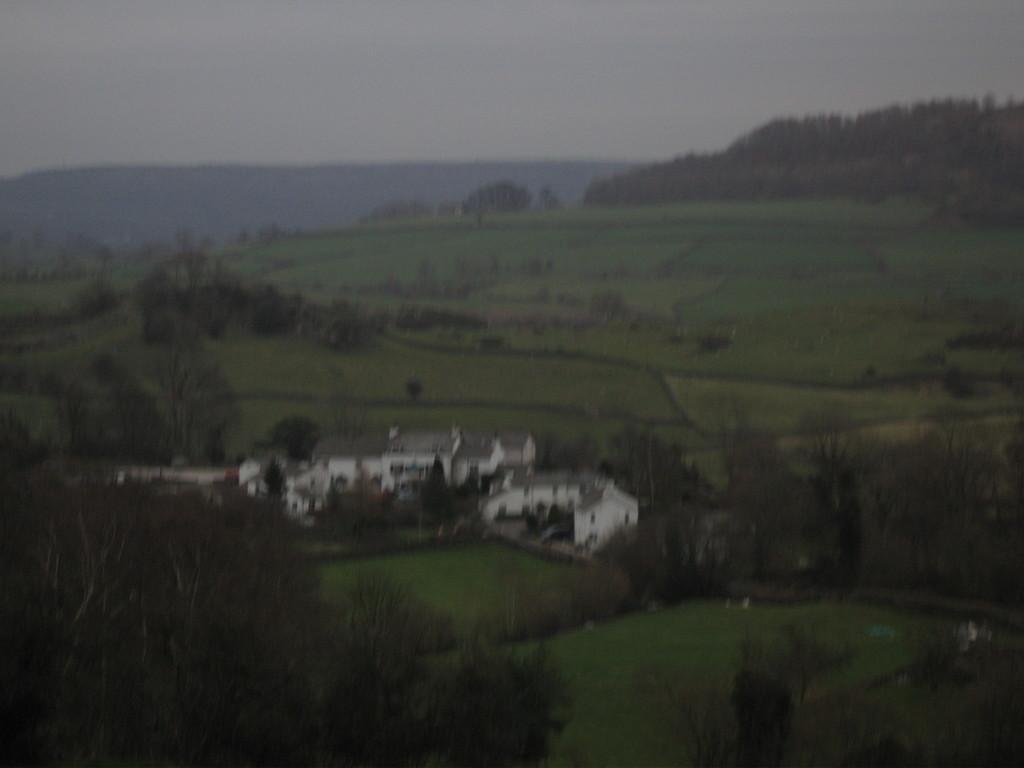How would you summarize this image in a sentence or two? In this picture i can see trees, buildings. In the background i can see sky. 